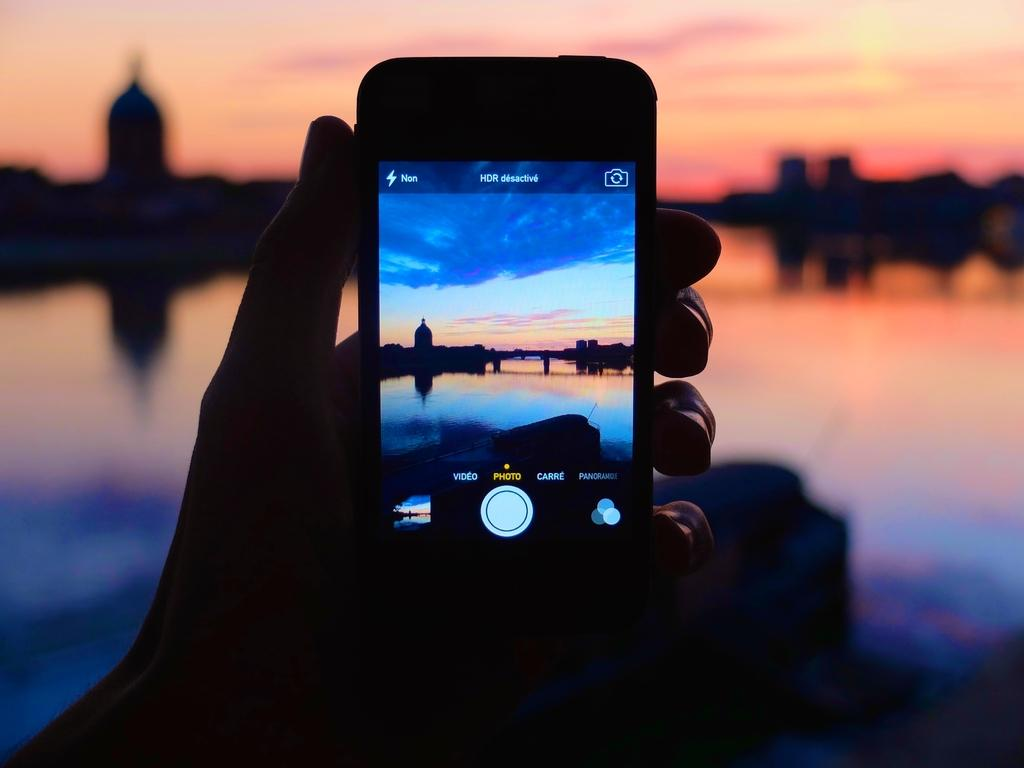<image>
Relay a brief, clear account of the picture shown. A cell phone shoes a camera screen and has options that say photo, video and carre. 